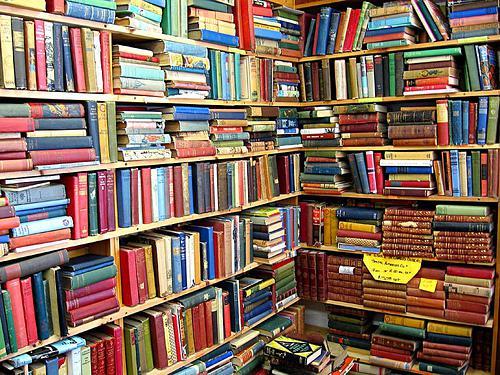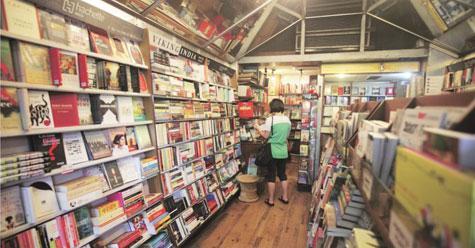The first image is the image on the left, the second image is the image on the right. Examine the images to the left and right. Is the description "Exactly one person, a standing woman, can be seen inside of a shop lined with bookshelves." accurate? Answer yes or no. Yes. The first image is the image on the left, the second image is the image on the right. For the images shown, is this caption "People are standing in a bookstore." true? Answer yes or no. Yes. 